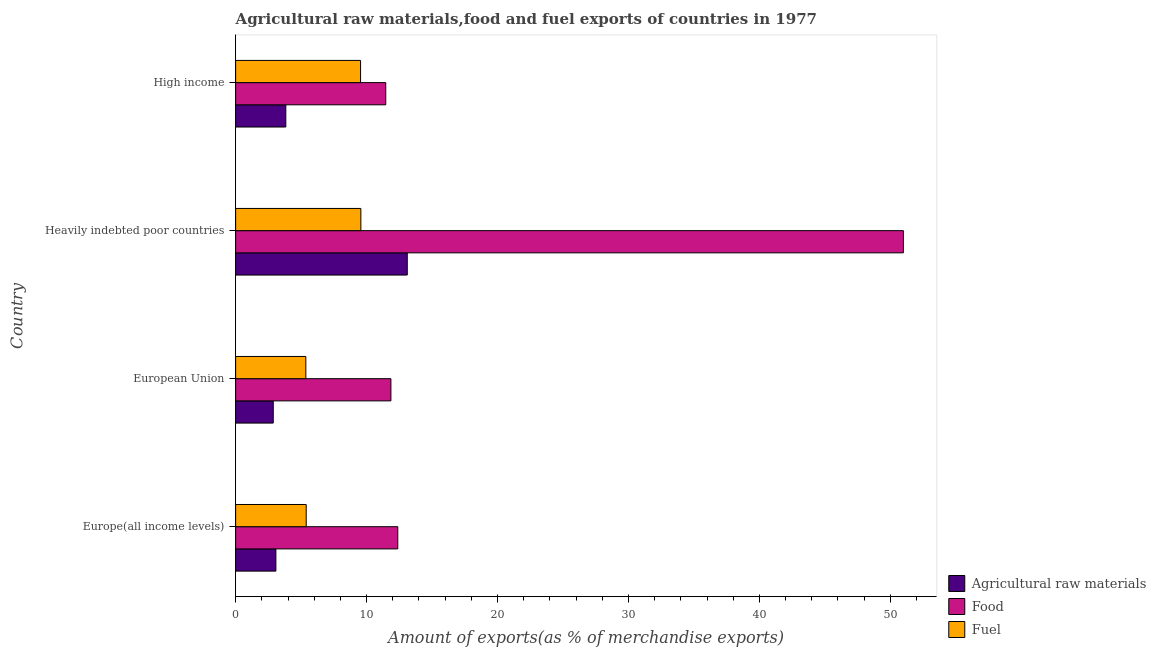Are the number of bars per tick equal to the number of legend labels?
Keep it short and to the point. Yes. Are the number of bars on each tick of the Y-axis equal?
Give a very brief answer. Yes. How many bars are there on the 3rd tick from the top?
Ensure brevity in your answer.  3. What is the label of the 4th group of bars from the top?
Offer a terse response. Europe(all income levels). What is the percentage of raw materials exports in Heavily indebted poor countries?
Ensure brevity in your answer.  13.11. Across all countries, what is the maximum percentage of food exports?
Provide a short and direct response. 50.99. Across all countries, what is the minimum percentage of food exports?
Offer a terse response. 11.47. In which country was the percentage of raw materials exports maximum?
Provide a succinct answer. Heavily indebted poor countries. What is the total percentage of food exports in the graph?
Provide a short and direct response. 86.7. What is the difference between the percentage of fuel exports in Europe(all income levels) and that in Heavily indebted poor countries?
Your response must be concise. -4.17. What is the difference between the percentage of food exports in High income and the percentage of raw materials exports in European Union?
Ensure brevity in your answer.  8.59. What is the average percentage of raw materials exports per country?
Your answer should be compact. 5.72. What is the difference between the percentage of raw materials exports and percentage of fuel exports in High income?
Your answer should be compact. -5.71. In how many countries, is the percentage of raw materials exports greater than 6 %?
Provide a short and direct response. 1. What is the ratio of the percentage of raw materials exports in Europe(all income levels) to that in High income?
Provide a succinct answer. 0.8. Is the percentage of raw materials exports in European Union less than that in High income?
Your answer should be very brief. Yes. What is the difference between the highest and the second highest percentage of raw materials exports?
Ensure brevity in your answer.  9.28. Is the sum of the percentage of raw materials exports in Europe(all income levels) and Heavily indebted poor countries greater than the maximum percentage of food exports across all countries?
Offer a terse response. No. What does the 3rd bar from the top in Europe(all income levels) represents?
Your answer should be very brief. Agricultural raw materials. What does the 3rd bar from the bottom in Heavily indebted poor countries represents?
Make the answer very short. Fuel. How many bars are there?
Provide a short and direct response. 12. What is the difference between two consecutive major ticks on the X-axis?
Ensure brevity in your answer.  10. Are the values on the major ticks of X-axis written in scientific E-notation?
Give a very brief answer. No. Does the graph contain any zero values?
Provide a short and direct response. No. Does the graph contain grids?
Your answer should be compact. No. Where does the legend appear in the graph?
Provide a succinct answer. Bottom right. What is the title of the graph?
Provide a short and direct response. Agricultural raw materials,food and fuel exports of countries in 1977. Does "Infant(female)" appear as one of the legend labels in the graph?
Keep it short and to the point. No. What is the label or title of the X-axis?
Offer a terse response. Amount of exports(as % of merchandise exports). What is the label or title of the Y-axis?
Keep it short and to the point. Country. What is the Amount of exports(as % of merchandise exports) in Agricultural raw materials in Europe(all income levels)?
Ensure brevity in your answer.  3.08. What is the Amount of exports(as % of merchandise exports) of Food in Europe(all income levels)?
Offer a terse response. 12.38. What is the Amount of exports(as % of merchandise exports) of Fuel in Europe(all income levels)?
Offer a very short reply. 5.39. What is the Amount of exports(as % of merchandise exports) of Agricultural raw materials in European Union?
Give a very brief answer. 2.87. What is the Amount of exports(as % of merchandise exports) in Food in European Union?
Your answer should be compact. 11.86. What is the Amount of exports(as % of merchandise exports) of Fuel in European Union?
Your response must be concise. 5.36. What is the Amount of exports(as % of merchandise exports) of Agricultural raw materials in Heavily indebted poor countries?
Make the answer very short. 13.11. What is the Amount of exports(as % of merchandise exports) in Food in Heavily indebted poor countries?
Give a very brief answer. 50.99. What is the Amount of exports(as % of merchandise exports) of Fuel in Heavily indebted poor countries?
Ensure brevity in your answer.  9.56. What is the Amount of exports(as % of merchandise exports) in Agricultural raw materials in High income?
Your answer should be compact. 3.83. What is the Amount of exports(as % of merchandise exports) of Food in High income?
Your answer should be very brief. 11.47. What is the Amount of exports(as % of merchandise exports) in Fuel in High income?
Keep it short and to the point. 9.54. Across all countries, what is the maximum Amount of exports(as % of merchandise exports) of Agricultural raw materials?
Provide a short and direct response. 13.11. Across all countries, what is the maximum Amount of exports(as % of merchandise exports) of Food?
Your response must be concise. 50.99. Across all countries, what is the maximum Amount of exports(as % of merchandise exports) in Fuel?
Keep it short and to the point. 9.56. Across all countries, what is the minimum Amount of exports(as % of merchandise exports) of Agricultural raw materials?
Your answer should be compact. 2.87. Across all countries, what is the minimum Amount of exports(as % of merchandise exports) of Food?
Make the answer very short. 11.47. Across all countries, what is the minimum Amount of exports(as % of merchandise exports) in Fuel?
Your answer should be compact. 5.36. What is the total Amount of exports(as % of merchandise exports) in Agricultural raw materials in the graph?
Ensure brevity in your answer.  22.89. What is the total Amount of exports(as % of merchandise exports) in Food in the graph?
Provide a succinct answer. 86.7. What is the total Amount of exports(as % of merchandise exports) of Fuel in the graph?
Offer a very short reply. 29.86. What is the difference between the Amount of exports(as % of merchandise exports) in Agricultural raw materials in Europe(all income levels) and that in European Union?
Offer a terse response. 0.2. What is the difference between the Amount of exports(as % of merchandise exports) in Food in Europe(all income levels) and that in European Union?
Provide a short and direct response. 0.53. What is the difference between the Amount of exports(as % of merchandise exports) in Fuel in Europe(all income levels) and that in European Union?
Provide a succinct answer. 0.03. What is the difference between the Amount of exports(as % of merchandise exports) in Agricultural raw materials in Europe(all income levels) and that in Heavily indebted poor countries?
Ensure brevity in your answer.  -10.03. What is the difference between the Amount of exports(as % of merchandise exports) in Food in Europe(all income levels) and that in Heavily indebted poor countries?
Give a very brief answer. -38.61. What is the difference between the Amount of exports(as % of merchandise exports) in Fuel in Europe(all income levels) and that in Heavily indebted poor countries?
Keep it short and to the point. -4.17. What is the difference between the Amount of exports(as % of merchandise exports) of Agricultural raw materials in Europe(all income levels) and that in High income?
Your answer should be very brief. -0.76. What is the difference between the Amount of exports(as % of merchandise exports) of Food in Europe(all income levels) and that in High income?
Provide a succinct answer. 0.92. What is the difference between the Amount of exports(as % of merchandise exports) of Fuel in Europe(all income levels) and that in High income?
Your answer should be compact. -4.15. What is the difference between the Amount of exports(as % of merchandise exports) of Agricultural raw materials in European Union and that in Heavily indebted poor countries?
Provide a succinct answer. -10.23. What is the difference between the Amount of exports(as % of merchandise exports) in Food in European Union and that in Heavily indebted poor countries?
Make the answer very short. -39.13. What is the difference between the Amount of exports(as % of merchandise exports) in Fuel in European Union and that in Heavily indebted poor countries?
Provide a short and direct response. -4.2. What is the difference between the Amount of exports(as % of merchandise exports) in Agricultural raw materials in European Union and that in High income?
Your answer should be compact. -0.96. What is the difference between the Amount of exports(as % of merchandise exports) of Food in European Union and that in High income?
Ensure brevity in your answer.  0.39. What is the difference between the Amount of exports(as % of merchandise exports) in Fuel in European Union and that in High income?
Your answer should be compact. -4.18. What is the difference between the Amount of exports(as % of merchandise exports) of Agricultural raw materials in Heavily indebted poor countries and that in High income?
Your answer should be compact. 9.27. What is the difference between the Amount of exports(as % of merchandise exports) in Food in Heavily indebted poor countries and that in High income?
Provide a succinct answer. 39.53. What is the difference between the Amount of exports(as % of merchandise exports) in Fuel in Heavily indebted poor countries and that in High income?
Your response must be concise. 0.02. What is the difference between the Amount of exports(as % of merchandise exports) of Agricultural raw materials in Europe(all income levels) and the Amount of exports(as % of merchandise exports) of Food in European Union?
Your answer should be very brief. -8.78. What is the difference between the Amount of exports(as % of merchandise exports) of Agricultural raw materials in Europe(all income levels) and the Amount of exports(as % of merchandise exports) of Fuel in European Union?
Ensure brevity in your answer.  -2.29. What is the difference between the Amount of exports(as % of merchandise exports) in Food in Europe(all income levels) and the Amount of exports(as % of merchandise exports) in Fuel in European Union?
Ensure brevity in your answer.  7.02. What is the difference between the Amount of exports(as % of merchandise exports) of Agricultural raw materials in Europe(all income levels) and the Amount of exports(as % of merchandise exports) of Food in Heavily indebted poor countries?
Offer a very short reply. -47.92. What is the difference between the Amount of exports(as % of merchandise exports) of Agricultural raw materials in Europe(all income levels) and the Amount of exports(as % of merchandise exports) of Fuel in Heavily indebted poor countries?
Give a very brief answer. -6.49. What is the difference between the Amount of exports(as % of merchandise exports) of Food in Europe(all income levels) and the Amount of exports(as % of merchandise exports) of Fuel in Heavily indebted poor countries?
Make the answer very short. 2.82. What is the difference between the Amount of exports(as % of merchandise exports) of Agricultural raw materials in Europe(all income levels) and the Amount of exports(as % of merchandise exports) of Food in High income?
Keep it short and to the point. -8.39. What is the difference between the Amount of exports(as % of merchandise exports) of Agricultural raw materials in Europe(all income levels) and the Amount of exports(as % of merchandise exports) of Fuel in High income?
Give a very brief answer. -6.47. What is the difference between the Amount of exports(as % of merchandise exports) in Food in Europe(all income levels) and the Amount of exports(as % of merchandise exports) in Fuel in High income?
Keep it short and to the point. 2.84. What is the difference between the Amount of exports(as % of merchandise exports) in Agricultural raw materials in European Union and the Amount of exports(as % of merchandise exports) in Food in Heavily indebted poor countries?
Make the answer very short. -48.12. What is the difference between the Amount of exports(as % of merchandise exports) of Agricultural raw materials in European Union and the Amount of exports(as % of merchandise exports) of Fuel in Heavily indebted poor countries?
Keep it short and to the point. -6.69. What is the difference between the Amount of exports(as % of merchandise exports) in Food in European Union and the Amount of exports(as % of merchandise exports) in Fuel in Heavily indebted poor countries?
Provide a succinct answer. 2.29. What is the difference between the Amount of exports(as % of merchandise exports) of Agricultural raw materials in European Union and the Amount of exports(as % of merchandise exports) of Food in High income?
Offer a very short reply. -8.59. What is the difference between the Amount of exports(as % of merchandise exports) of Agricultural raw materials in European Union and the Amount of exports(as % of merchandise exports) of Fuel in High income?
Ensure brevity in your answer.  -6.67. What is the difference between the Amount of exports(as % of merchandise exports) of Food in European Union and the Amount of exports(as % of merchandise exports) of Fuel in High income?
Keep it short and to the point. 2.32. What is the difference between the Amount of exports(as % of merchandise exports) of Agricultural raw materials in Heavily indebted poor countries and the Amount of exports(as % of merchandise exports) of Food in High income?
Make the answer very short. 1.64. What is the difference between the Amount of exports(as % of merchandise exports) of Agricultural raw materials in Heavily indebted poor countries and the Amount of exports(as % of merchandise exports) of Fuel in High income?
Offer a very short reply. 3.57. What is the difference between the Amount of exports(as % of merchandise exports) of Food in Heavily indebted poor countries and the Amount of exports(as % of merchandise exports) of Fuel in High income?
Provide a short and direct response. 41.45. What is the average Amount of exports(as % of merchandise exports) in Agricultural raw materials per country?
Offer a very short reply. 5.72. What is the average Amount of exports(as % of merchandise exports) in Food per country?
Your answer should be very brief. 21.68. What is the average Amount of exports(as % of merchandise exports) in Fuel per country?
Provide a short and direct response. 7.46. What is the difference between the Amount of exports(as % of merchandise exports) in Agricultural raw materials and Amount of exports(as % of merchandise exports) in Food in Europe(all income levels)?
Your answer should be very brief. -9.31. What is the difference between the Amount of exports(as % of merchandise exports) of Agricultural raw materials and Amount of exports(as % of merchandise exports) of Fuel in Europe(all income levels)?
Offer a very short reply. -2.31. What is the difference between the Amount of exports(as % of merchandise exports) in Food and Amount of exports(as % of merchandise exports) in Fuel in Europe(all income levels)?
Offer a terse response. 6.99. What is the difference between the Amount of exports(as % of merchandise exports) in Agricultural raw materials and Amount of exports(as % of merchandise exports) in Food in European Union?
Keep it short and to the point. -8.98. What is the difference between the Amount of exports(as % of merchandise exports) in Agricultural raw materials and Amount of exports(as % of merchandise exports) in Fuel in European Union?
Your answer should be compact. -2.49. What is the difference between the Amount of exports(as % of merchandise exports) of Food and Amount of exports(as % of merchandise exports) of Fuel in European Union?
Give a very brief answer. 6.5. What is the difference between the Amount of exports(as % of merchandise exports) of Agricultural raw materials and Amount of exports(as % of merchandise exports) of Food in Heavily indebted poor countries?
Give a very brief answer. -37.89. What is the difference between the Amount of exports(as % of merchandise exports) in Agricultural raw materials and Amount of exports(as % of merchandise exports) in Fuel in Heavily indebted poor countries?
Ensure brevity in your answer.  3.54. What is the difference between the Amount of exports(as % of merchandise exports) of Food and Amount of exports(as % of merchandise exports) of Fuel in Heavily indebted poor countries?
Your response must be concise. 41.43. What is the difference between the Amount of exports(as % of merchandise exports) in Agricultural raw materials and Amount of exports(as % of merchandise exports) in Food in High income?
Your answer should be compact. -7.63. What is the difference between the Amount of exports(as % of merchandise exports) of Agricultural raw materials and Amount of exports(as % of merchandise exports) of Fuel in High income?
Your response must be concise. -5.71. What is the difference between the Amount of exports(as % of merchandise exports) of Food and Amount of exports(as % of merchandise exports) of Fuel in High income?
Provide a short and direct response. 1.92. What is the ratio of the Amount of exports(as % of merchandise exports) in Agricultural raw materials in Europe(all income levels) to that in European Union?
Ensure brevity in your answer.  1.07. What is the ratio of the Amount of exports(as % of merchandise exports) in Food in Europe(all income levels) to that in European Union?
Your answer should be compact. 1.04. What is the ratio of the Amount of exports(as % of merchandise exports) in Fuel in Europe(all income levels) to that in European Union?
Give a very brief answer. 1.01. What is the ratio of the Amount of exports(as % of merchandise exports) in Agricultural raw materials in Europe(all income levels) to that in Heavily indebted poor countries?
Provide a succinct answer. 0.23. What is the ratio of the Amount of exports(as % of merchandise exports) of Food in Europe(all income levels) to that in Heavily indebted poor countries?
Provide a succinct answer. 0.24. What is the ratio of the Amount of exports(as % of merchandise exports) in Fuel in Europe(all income levels) to that in Heavily indebted poor countries?
Make the answer very short. 0.56. What is the ratio of the Amount of exports(as % of merchandise exports) in Agricultural raw materials in Europe(all income levels) to that in High income?
Provide a short and direct response. 0.8. What is the ratio of the Amount of exports(as % of merchandise exports) in Food in Europe(all income levels) to that in High income?
Make the answer very short. 1.08. What is the ratio of the Amount of exports(as % of merchandise exports) of Fuel in Europe(all income levels) to that in High income?
Your response must be concise. 0.56. What is the ratio of the Amount of exports(as % of merchandise exports) in Agricultural raw materials in European Union to that in Heavily indebted poor countries?
Provide a succinct answer. 0.22. What is the ratio of the Amount of exports(as % of merchandise exports) of Food in European Union to that in Heavily indebted poor countries?
Give a very brief answer. 0.23. What is the ratio of the Amount of exports(as % of merchandise exports) in Fuel in European Union to that in Heavily indebted poor countries?
Ensure brevity in your answer.  0.56. What is the ratio of the Amount of exports(as % of merchandise exports) of Agricultural raw materials in European Union to that in High income?
Your answer should be very brief. 0.75. What is the ratio of the Amount of exports(as % of merchandise exports) of Food in European Union to that in High income?
Your answer should be very brief. 1.03. What is the ratio of the Amount of exports(as % of merchandise exports) in Fuel in European Union to that in High income?
Your answer should be compact. 0.56. What is the ratio of the Amount of exports(as % of merchandise exports) in Agricultural raw materials in Heavily indebted poor countries to that in High income?
Keep it short and to the point. 3.42. What is the ratio of the Amount of exports(as % of merchandise exports) in Food in Heavily indebted poor countries to that in High income?
Ensure brevity in your answer.  4.45. What is the difference between the highest and the second highest Amount of exports(as % of merchandise exports) in Agricultural raw materials?
Provide a short and direct response. 9.27. What is the difference between the highest and the second highest Amount of exports(as % of merchandise exports) of Food?
Provide a succinct answer. 38.61. What is the difference between the highest and the second highest Amount of exports(as % of merchandise exports) of Fuel?
Ensure brevity in your answer.  0.02. What is the difference between the highest and the lowest Amount of exports(as % of merchandise exports) of Agricultural raw materials?
Provide a succinct answer. 10.23. What is the difference between the highest and the lowest Amount of exports(as % of merchandise exports) in Food?
Ensure brevity in your answer.  39.53. What is the difference between the highest and the lowest Amount of exports(as % of merchandise exports) in Fuel?
Ensure brevity in your answer.  4.2. 